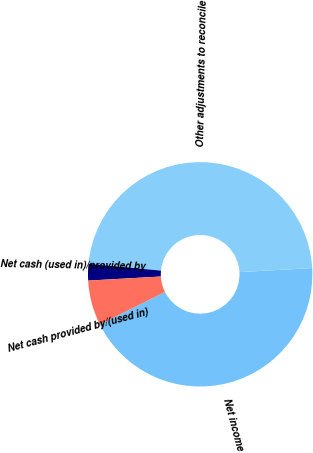Convert chart. <chart><loc_0><loc_0><loc_500><loc_500><pie_chart><fcel>Net income<fcel>Other adjustments to reconcile<fcel>Net cash (used in)/provided by<fcel>Net cash provided by/(used in)<nl><fcel>43.51%<fcel>47.62%<fcel>2.38%<fcel>6.49%<nl></chart> 